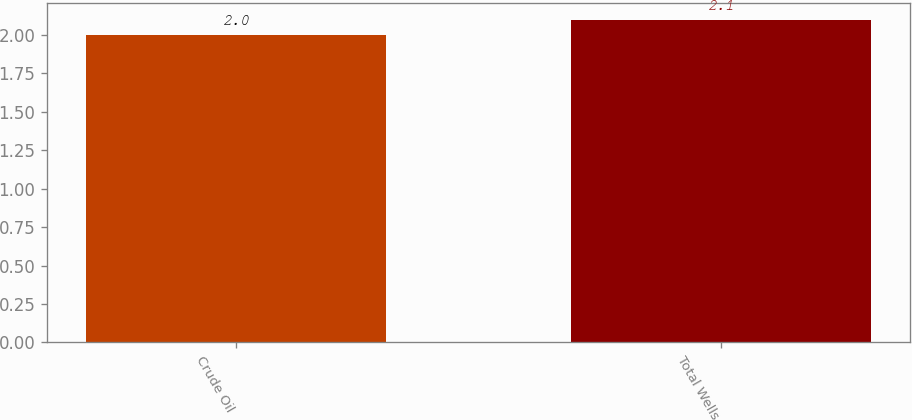<chart> <loc_0><loc_0><loc_500><loc_500><bar_chart><fcel>Crude Oil<fcel>Total Wells<nl><fcel>2<fcel>2.1<nl></chart> 